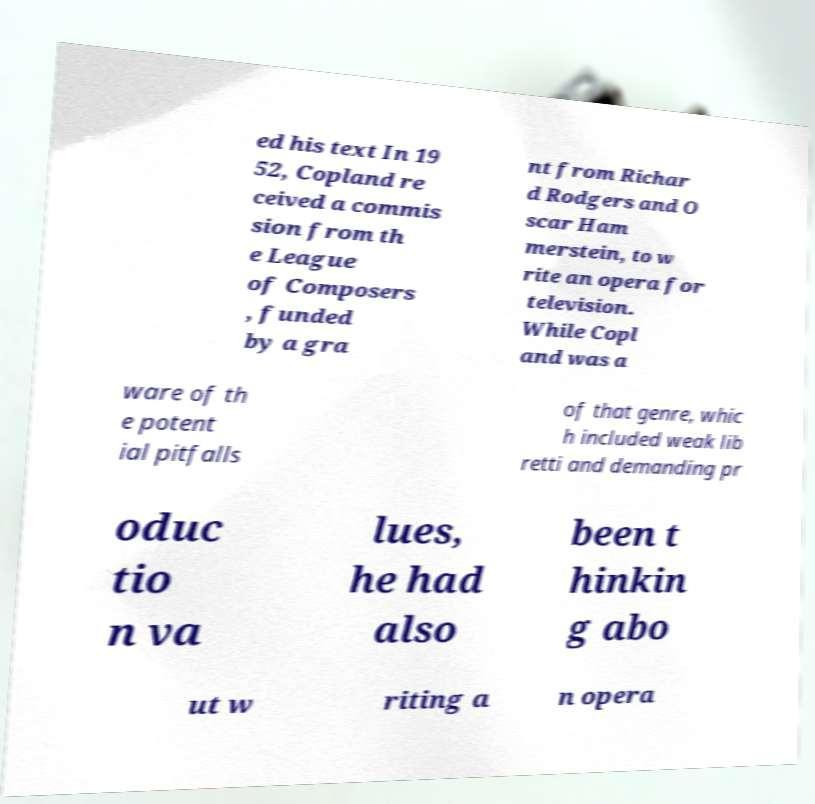Can you read and provide the text displayed in the image?This photo seems to have some interesting text. Can you extract and type it out for me? ed his text In 19 52, Copland re ceived a commis sion from th e League of Composers , funded by a gra nt from Richar d Rodgers and O scar Ham merstein, to w rite an opera for television. While Copl and was a ware of th e potent ial pitfalls of that genre, whic h included weak lib retti and demanding pr oduc tio n va lues, he had also been t hinkin g abo ut w riting a n opera 